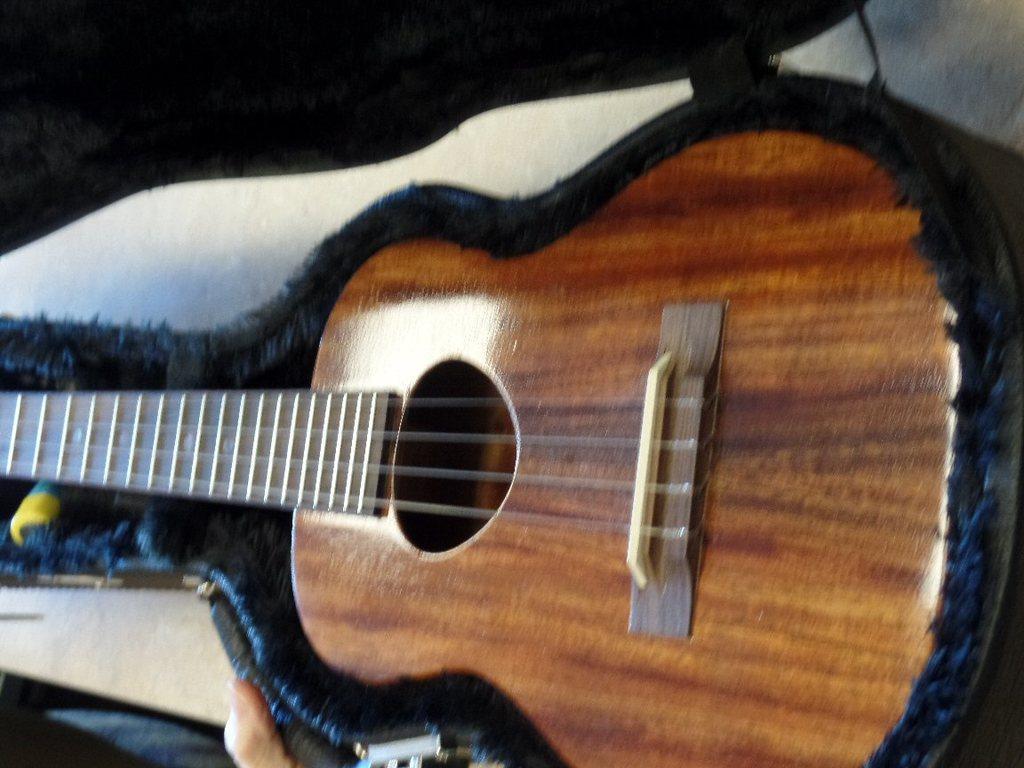Could you give a brief overview of what you see in this image? There is a guitar with strings on it. 